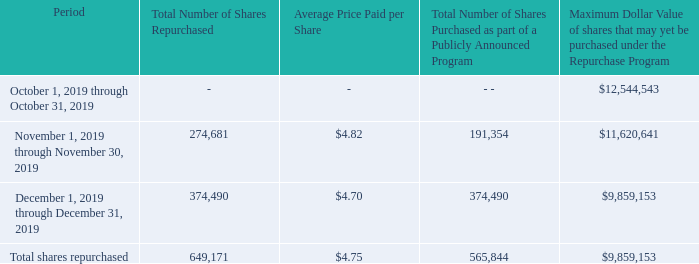Net Settlement of Equity Awards
The majority of restricted stock units are subject to vesting. The underlying shares of common stock are issued when the restricted stock units vest. The majority of participants choose to participate in a broker-assisted automatic sales program to satisfy their applicable tax withholding requirements. We do not treat the shares sold pursuant to this automatic sales program as common stock repurchases.
In the fourth quarter of 2019, we withheld 83,327 shares through net settlements (where the award holder receives the net of the shares vested, after surrendering a portion of the shares back to the Company for tax withholding) for restricted stock units that vested for some of our executive officers.
The following table provides a summary of the Company’s repurchase of common stock under the Repurchase Program and shares surrendered back to the Company for tax withholding on restricted stock units that vested under our equity incentive programs in the three months ended December 31, 2019:
What is the Maximum Dollar Value of shares that may yet be purchased under the Repurchase Program during October 1, 2019 through October 31, 2019 and during November 1, 2019 through November 30, 2019 respectively? 12,544,543, 11,620,641. What is the total number of shares repurchased for December 1, 2019 through December 31, 2019 and for November 1, 2019 through November 30, 2019 respectively? 374,490, 274,681. When are the underlying shares of common stock issued? When the restricted stock units vest. What is the total Maximum Dollar Value of shares that may yet be purchased under the Repurchase Program during October 1, 2019 through November 30, 2019? 12,544,543+11,620,641
Answer: 24165184. What is the percentage change in total Number of Shares Purchased as part of a Publicly Announced Program from November to December 2019?
Answer scale should be: percent. (374,490-191,354)/191,354
Answer: 0.96. From November 1 2019 to December 31 2019, how many months was the average price paid per share more than $4.72? November
Answer: 1. 